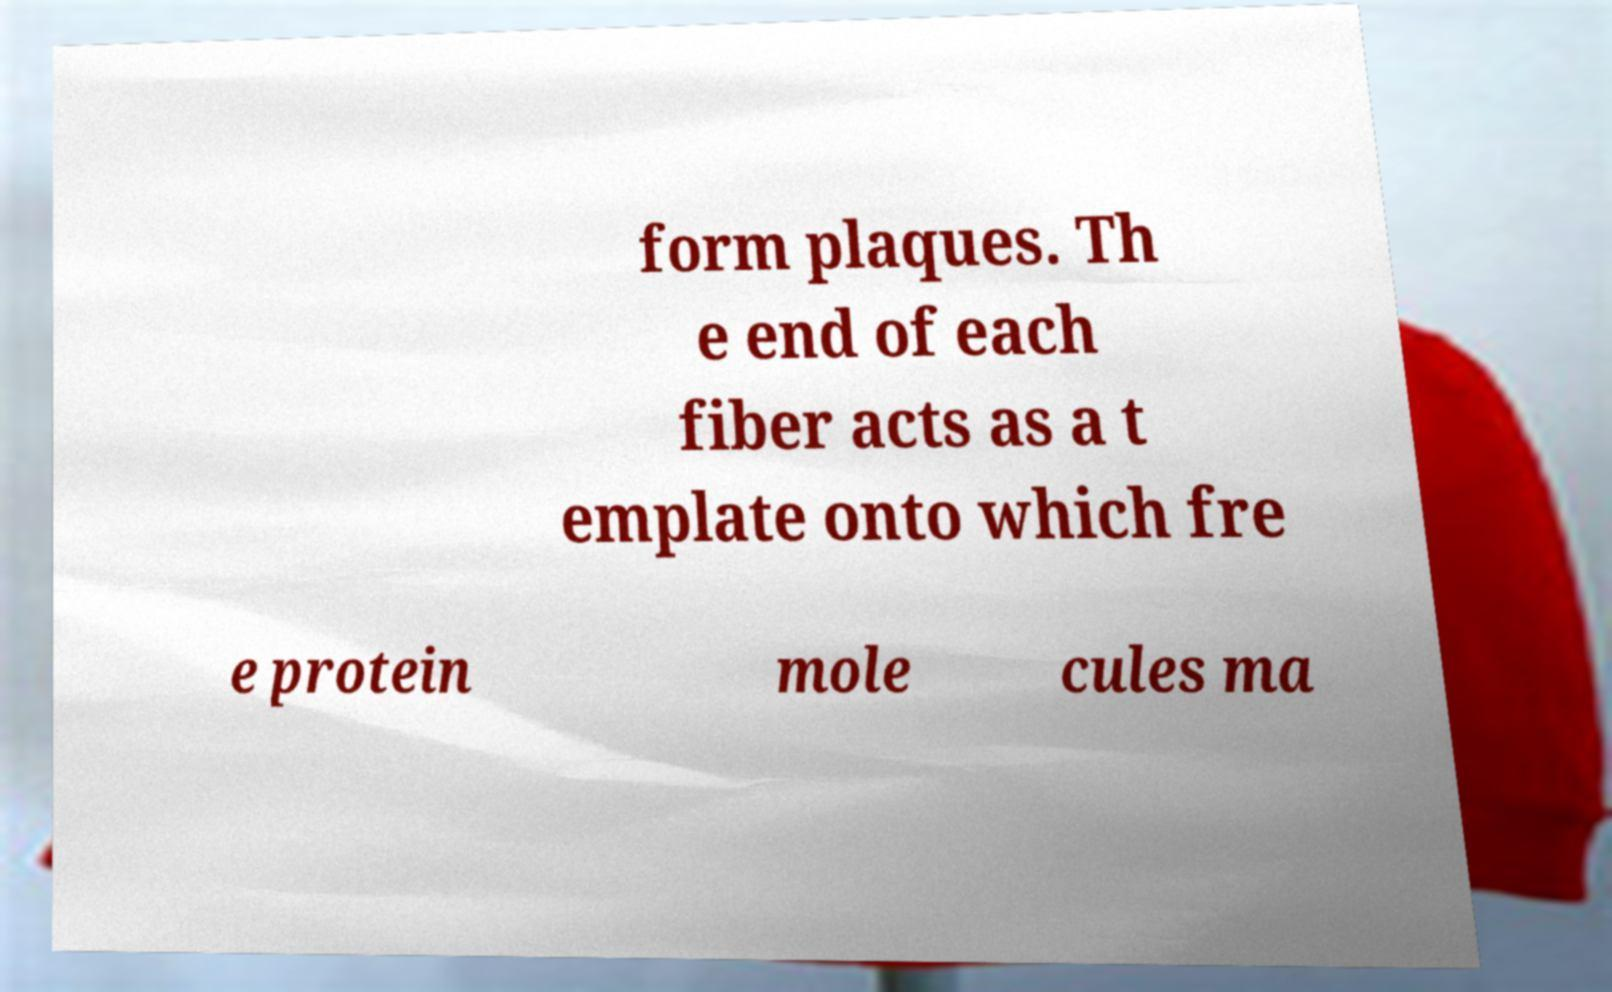For documentation purposes, I need the text within this image transcribed. Could you provide that? form plaques. Th e end of each fiber acts as a t emplate onto which fre e protein mole cules ma 